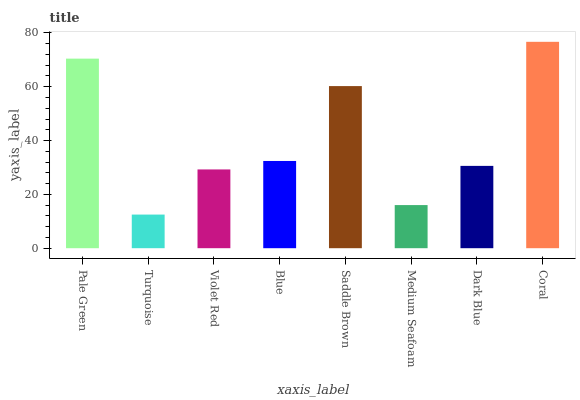Is Turquoise the minimum?
Answer yes or no. Yes. Is Coral the maximum?
Answer yes or no. Yes. Is Violet Red the minimum?
Answer yes or no. No. Is Violet Red the maximum?
Answer yes or no. No. Is Violet Red greater than Turquoise?
Answer yes or no. Yes. Is Turquoise less than Violet Red?
Answer yes or no. Yes. Is Turquoise greater than Violet Red?
Answer yes or no. No. Is Violet Red less than Turquoise?
Answer yes or no. No. Is Blue the high median?
Answer yes or no. Yes. Is Dark Blue the low median?
Answer yes or no. Yes. Is Medium Seafoam the high median?
Answer yes or no. No. Is Saddle Brown the low median?
Answer yes or no. No. 